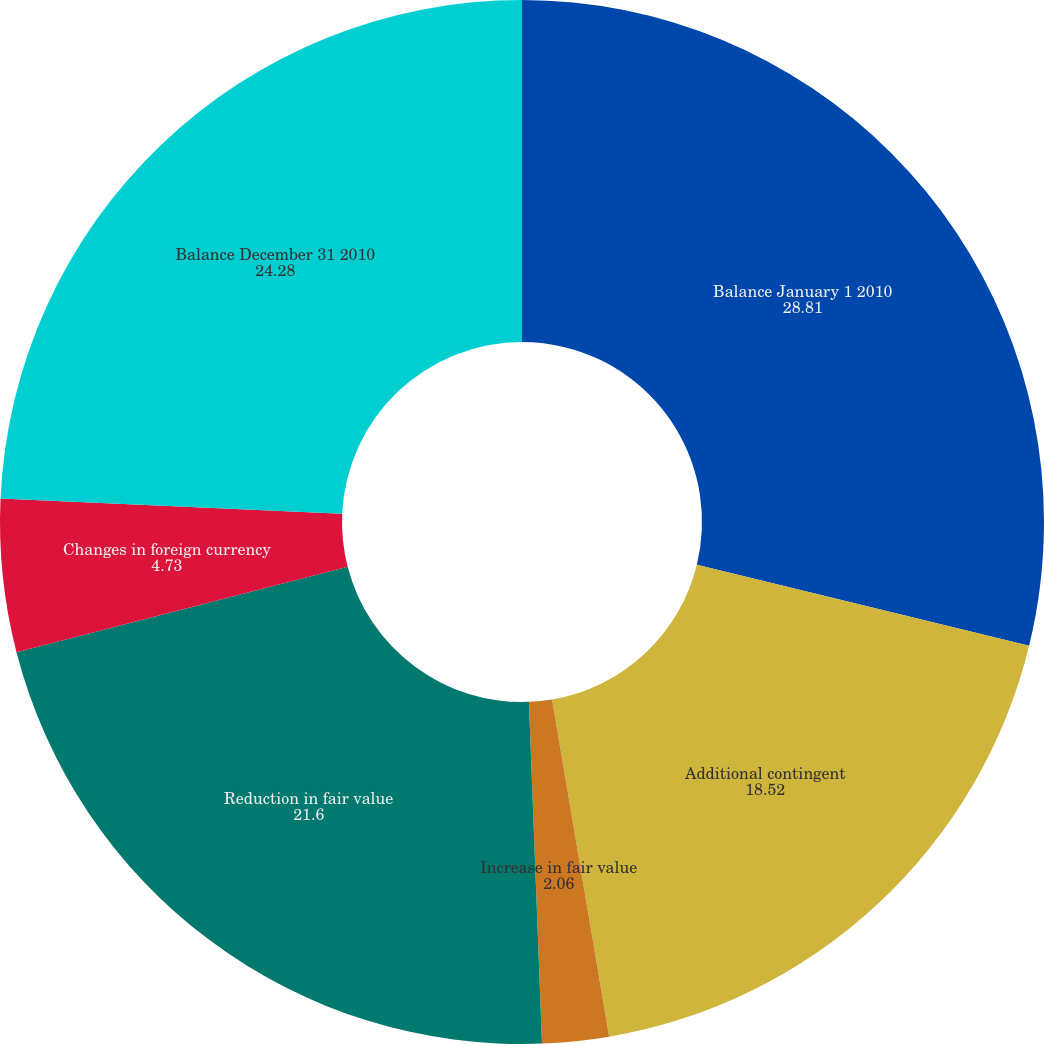Convert chart to OTSL. <chart><loc_0><loc_0><loc_500><loc_500><pie_chart><fcel>Balance January 1 2010<fcel>Additional contingent<fcel>Increase in fair value<fcel>Reduction in fair value<fcel>Changes in foreign currency<fcel>Balance December 31 2010<nl><fcel>28.81%<fcel>18.52%<fcel>2.06%<fcel>21.6%<fcel>4.73%<fcel>24.28%<nl></chart> 